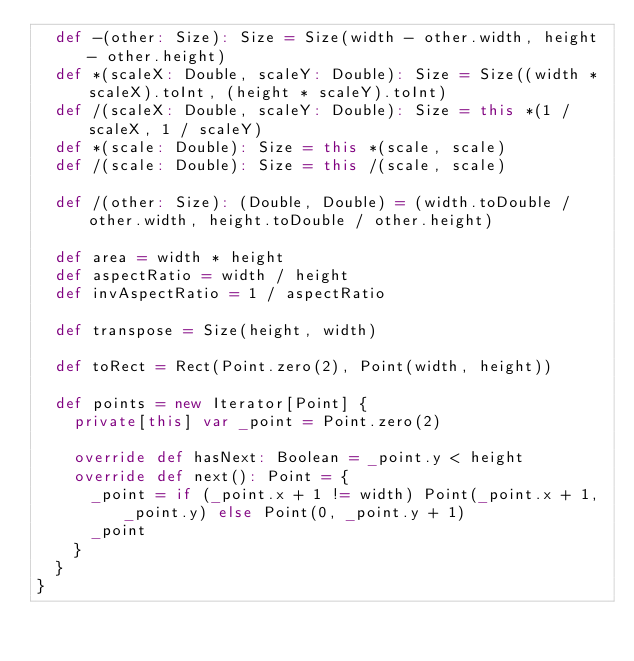<code> <loc_0><loc_0><loc_500><loc_500><_Scala_>  def -(other: Size): Size = Size(width - other.width, height - other.height)
  def *(scaleX: Double, scaleY: Double): Size = Size((width * scaleX).toInt, (height * scaleY).toInt)
  def /(scaleX: Double, scaleY: Double): Size = this *(1 / scaleX, 1 / scaleY)
  def *(scale: Double): Size = this *(scale, scale)
  def /(scale: Double): Size = this /(scale, scale)

  def /(other: Size): (Double, Double) = (width.toDouble / other.width, height.toDouble / other.height)

  def area = width * height
  def aspectRatio = width / height
  def invAspectRatio = 1 / aspectRatio

  def transpose = Size(height, width)

  def toRect = Rect(Point.zero(2), Point(width, height))

  def points = new Iterator[Point] {
    private[this] var _point = Point.zero(2)

    override def hasNext: Boolean = _point.y < height
    override def next(): Point = {
      _point = if (_point.x + 1 != width) Point(_point.x + 1, _point.y) else Point(0, _point.y + 1)
      _point
    }
  }
}
</code> 